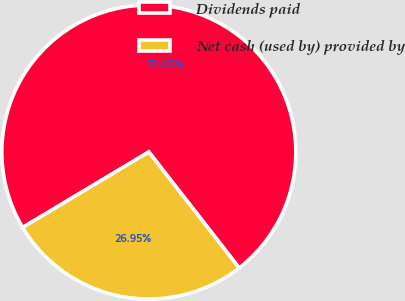Convert chart to OTSL. <chart><loc_0><loc_0><loc_500><loc_500><pie_chart><fcel>Dividends paid<fcel>Net cash (used by) provided by<nl><fcel>73.05%<fcel>26.95%<nl></chart> 